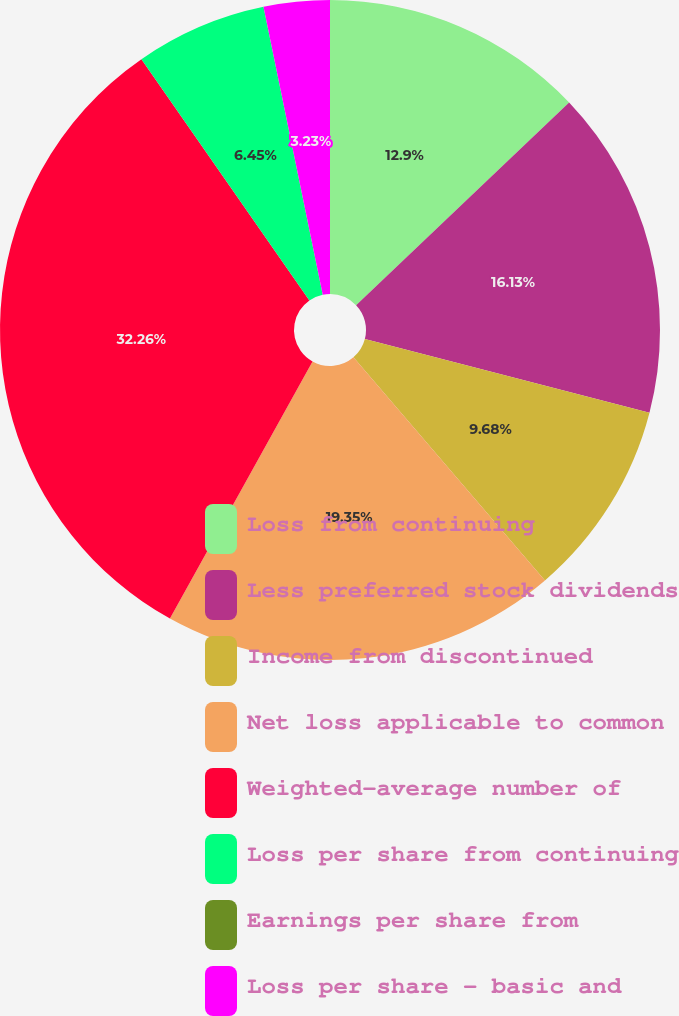<chart> <loc_0><loc_0><loc_500><loc_500><pie_chart><fcel>Loss from continuing<fcel>Less preferred stock dividends<fcel>Income from discontinued<fcel>Net loss applicable to common<fcel>Weighted-average number of<fcel>Loss per share from continuing<fcel>Earnings per share from<fcel>Loss per share - basic and<nl><fcel>12.9%<fcel>16.13%<fcel>9.68%<fcel>19.35%<fcel>32.26%<fcel>6.45%<fcel>0.0%<fcel>3.23%<nl></chart> 